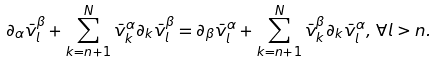<formula> <loc_0><loc_0><loc_500><loc_500>\partial _ { \alpha } \bar { v } ^ { \beta } _ { l } + \sum _ { k = n + 1 } ^ { N } \bar { v } _ { k } ^ { \alpha } \partial _ { k } \bar { v } _ { l } ^ { \beta } = \partial _ { \beta } \bar { v } ^ { \alpha } _ { l } + \sum _ { k = n + 1 } ^ { N } \bar { v } _ { k } ^ { \beta } \partial _ { k } \bar { v } _ { l } ^ { \alpha } , \, \forall l > n .</formula> 